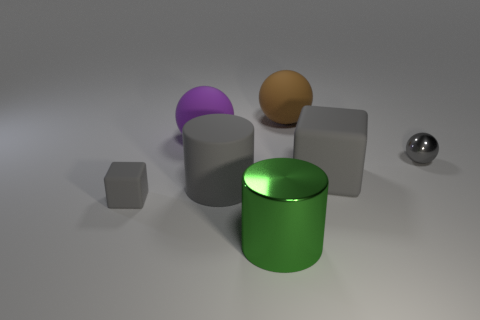Subtract all yellow cubes. Subtract all yellow balls. How many cubes are left? 2 Add 1 brown things. How many objects exist? 8 Subtract all blocks. How many objects are left? 5 Subtract all tiny yellow rubber cubes. Subtract all brown spheres. How many objects are left? 6 Add 5 big purple rubber balls. How many big purple rubber balls are left? 6 Add 3 large red metal things. How many large red metal things exist? 3 Subtract 0 blue cylinders. How many objects are left? 7 